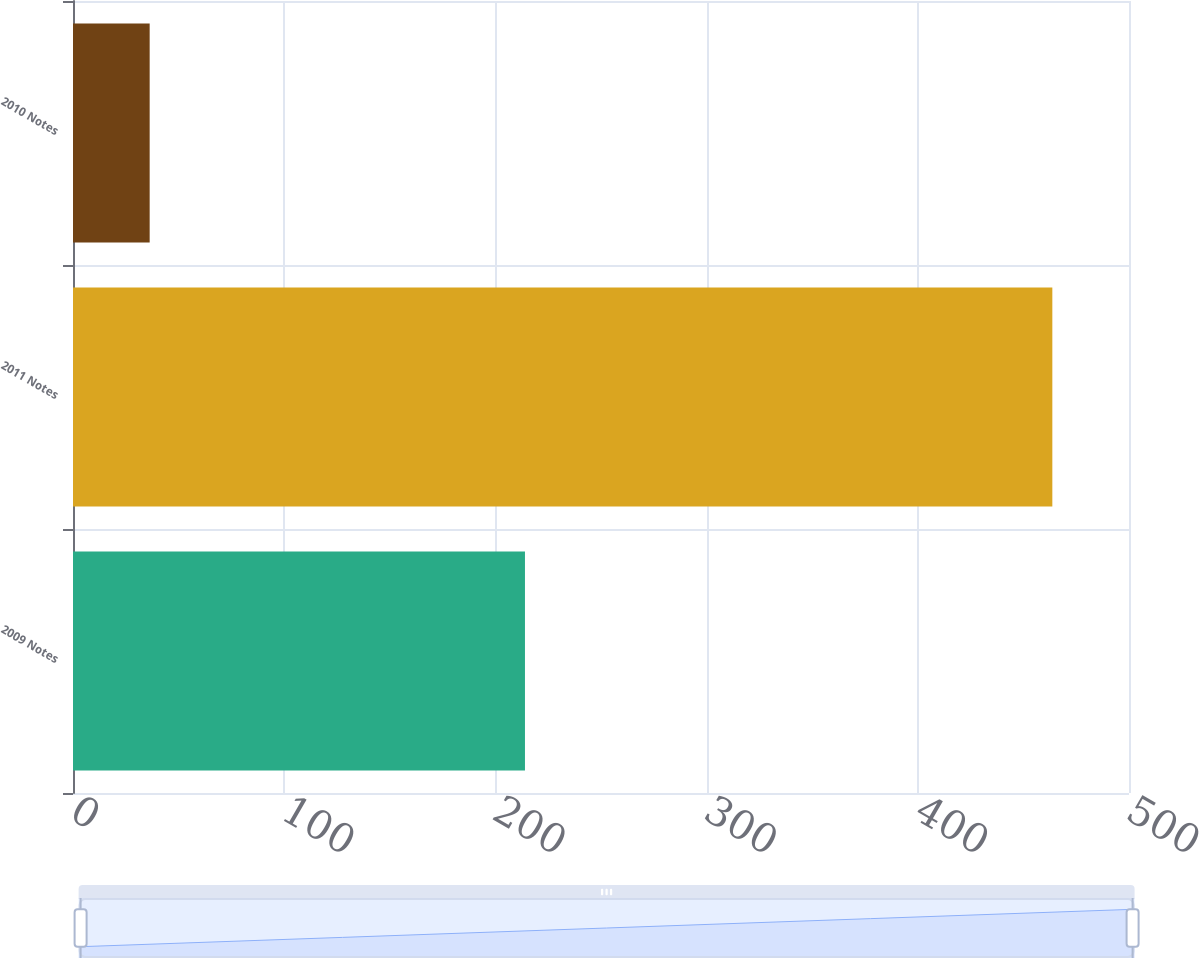Convert chart. <chart><loc_0><loc_0><loc_500><loc_500><bar_chart><fcel>2009 Notes<fcel>2011 Notes<fcel>2010 Notes<nl><fcel>214<fcel>463.7<fcel>36.3<nl></chart> 